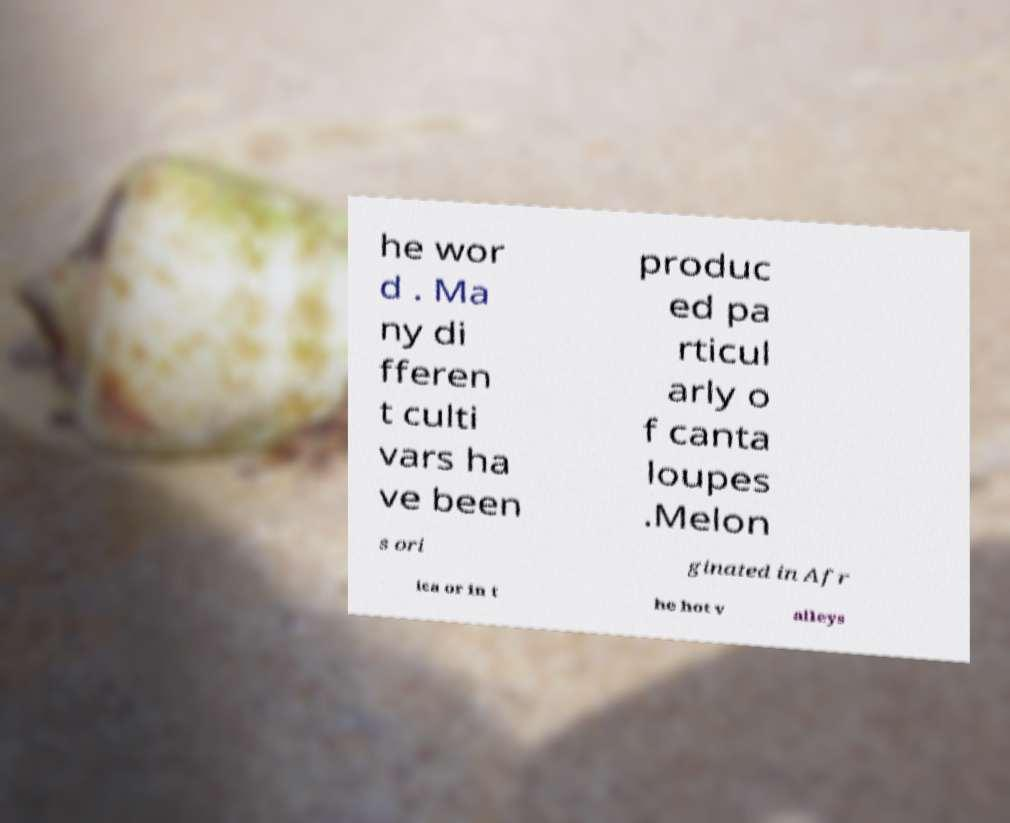Could you extract and type out the text from this image? he wor d . Ma ny di fferen t culti vars ha ve been produc ed pa rticul arly o f canta loupes .Melon s ori ginated in Afr ica or in t he hot v alleys 